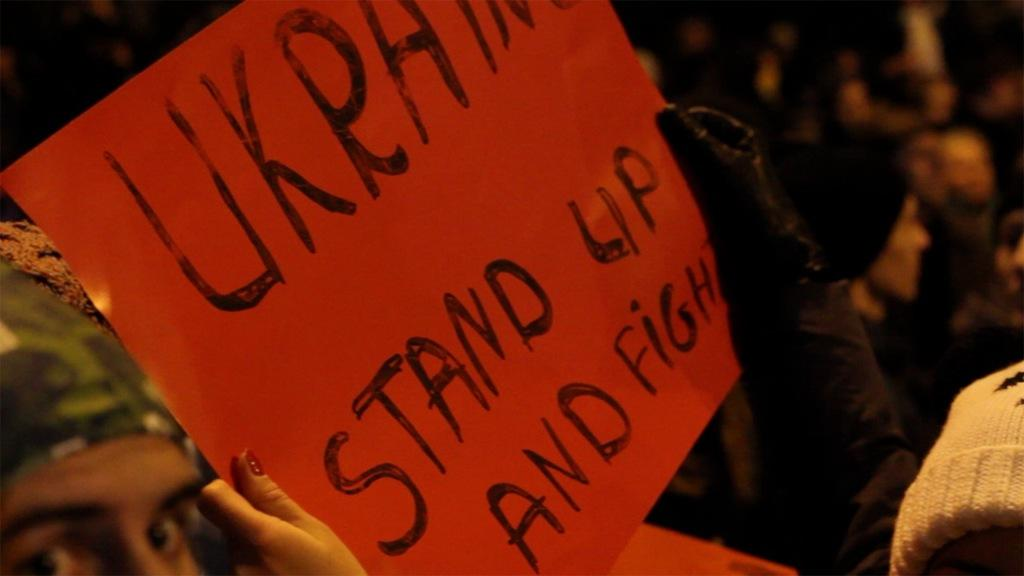What color is the board that is visible in the image? There is a red color board in the image. What is written on the board? Something is written on the board. Who is holding the board in the image? A person is holding the board. Can you describe the background of the image? The background is blurred. Is the person's father standing on the bridge in the background of the image? There is no bridge or father present in the image; it only features a red color board with something written on it, held by a person. 